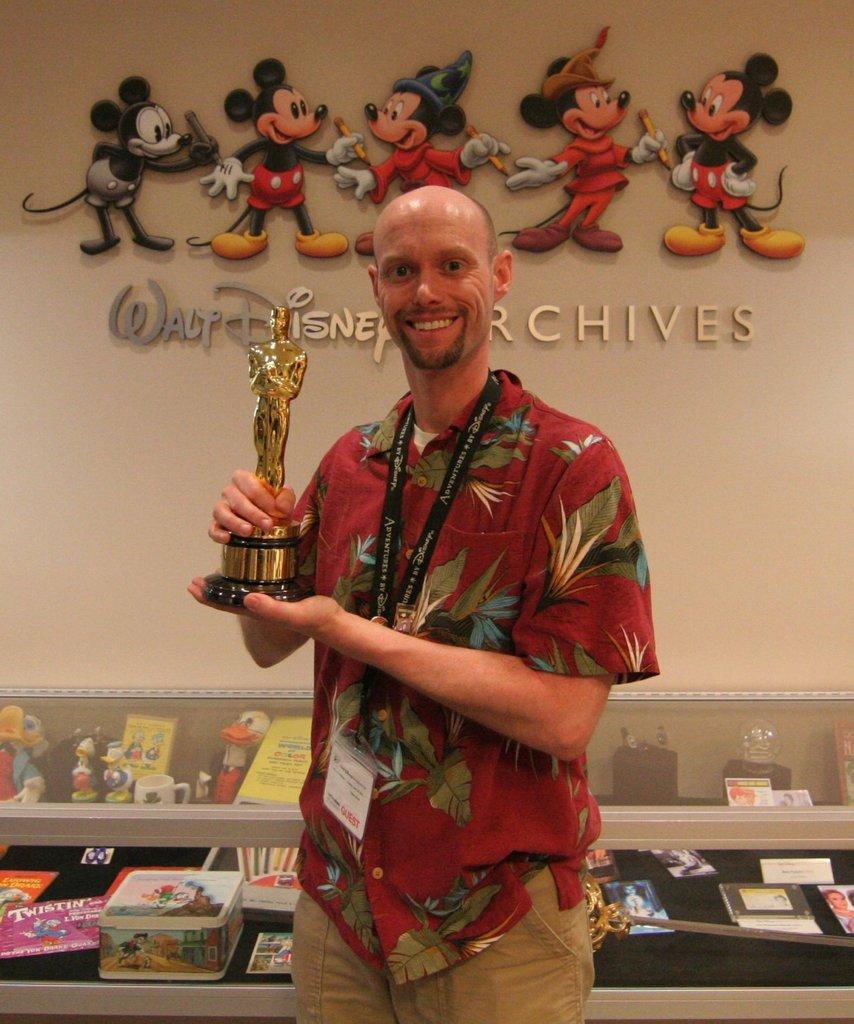How would you summarize this image in a sentence or two? As we can see in the image there is a wall, statue and a man wearing red color shirt. There are boxes, toys, glasses and books. 